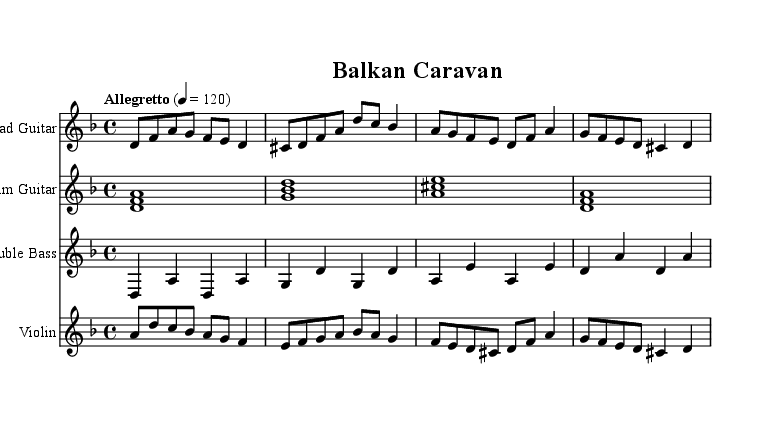What is the key signature of this music? The key signature is D minor, which has one flat (B flat). This can be determined by examining the initial key signature markings at the beginning of the staff.
Answer: D minor What is the time signature of the piece? The time signature is 4/4, which is indicated at the beginning of the score. This means there are four beats in each measure, and each beat is a quarter note.
Answer: 4/4 What is the tempo marking for this piece? The tempo marking reads "Allegretto" with a metronome marking of 120 beats per minute. This is noted at the start of the global section of the score, suggesting a moderately fast pace.
Answer: Allegretto 120 How many measures are in the lead guitar part? The lead guitar part contains 4 measures. By counting the bars in the notation of the lead guitar section, we find exactly four.
Answer: 4 Which instrument has the lowest pitch range in this score? The double bass has the lowest pitch range in this score. This is determined by comparing the notated pitches of each instrument, and the double bass consistently plays the lowest notes.
Answer: Double Bass In which section does the violin predominantly play ascending melodies? The violin predominantly plays ascending melodies in measures 1 to 3. By analyzing the notes played within these measures, we see the pitches primarily increase.
Answer: Measures 1 to 3 What type of chord is used in the rhythm guitar part? The rhythm guitar part uses major chords, as seen in the chord symbols indicated. Each chord is structured in a major triad formation.
Answer: Major chords 